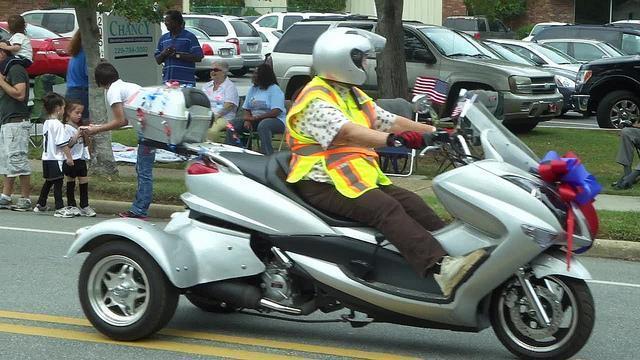How many cars can you see?
Give a very brief answer. 4. How many people are there?
Give a very brief answer. 7. How many umbrellas in this picture are yellow?
Give a very brief answer. 0. 